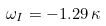Convert formula to latex. <formula><loc_0><loc_0><loc_500><loc_500>\omega _ { I } = - 1 . 2 9 \, \kappa</formula> 